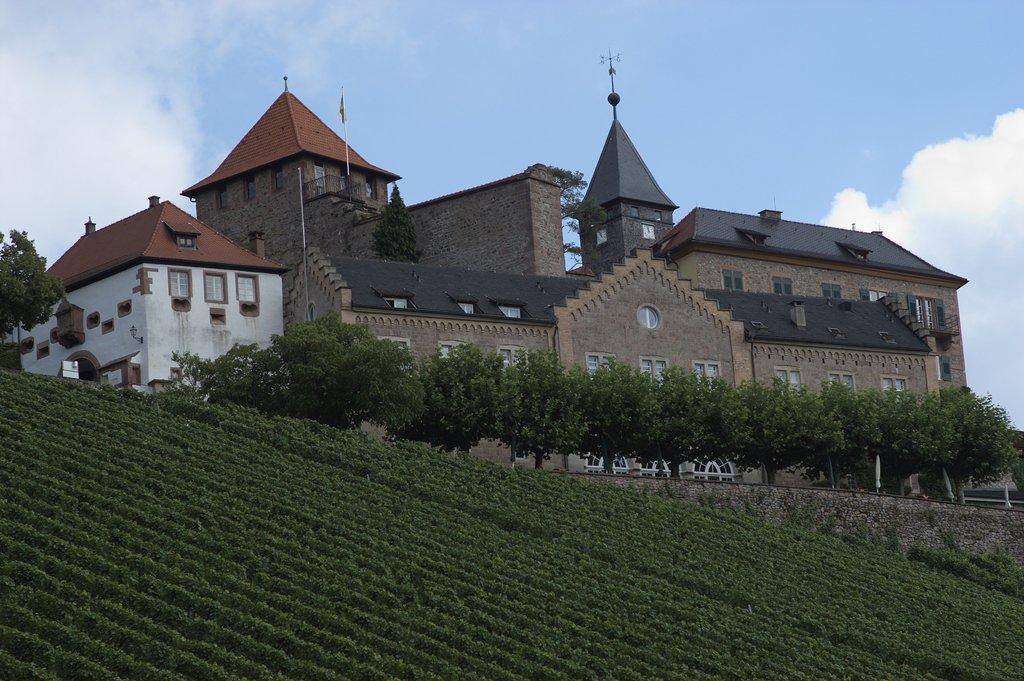Please provide a concise description of this image. In this image, we can see green color plants and trees, we can see a building, at the top there is a blue color sky. 